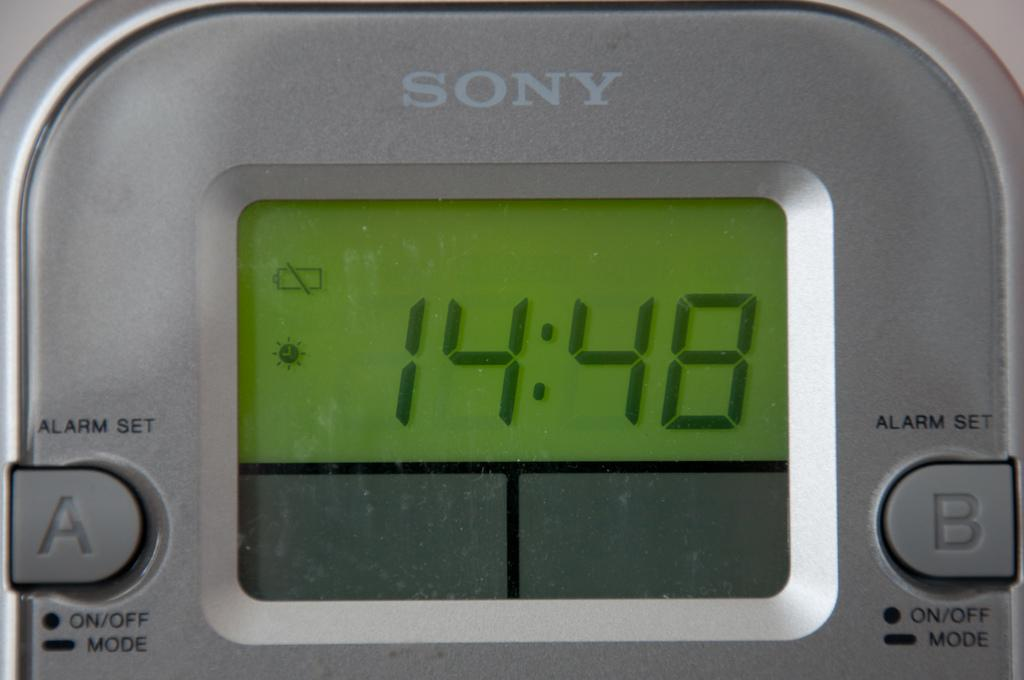<image>
Write a terse but informative summary of the picture. A song device reads the time of 14:48. 